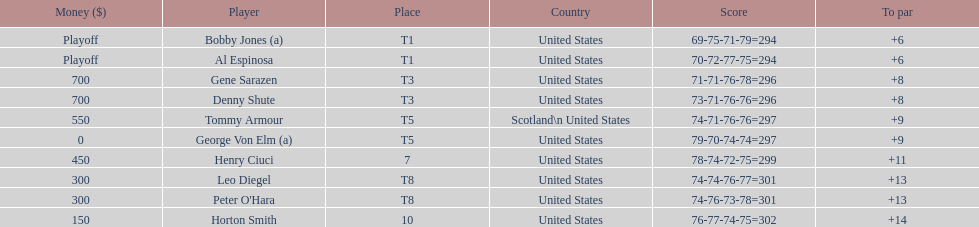Gene sarazen and denny shute are both from which country? United States. 